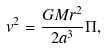<formula> <loc_0><loc_0><loc_500><loc_500>v ^ { 2 } = \frac { G M r ^ { 2 } } { 2 a ^ { 3 } } \Pi ,</formula> 